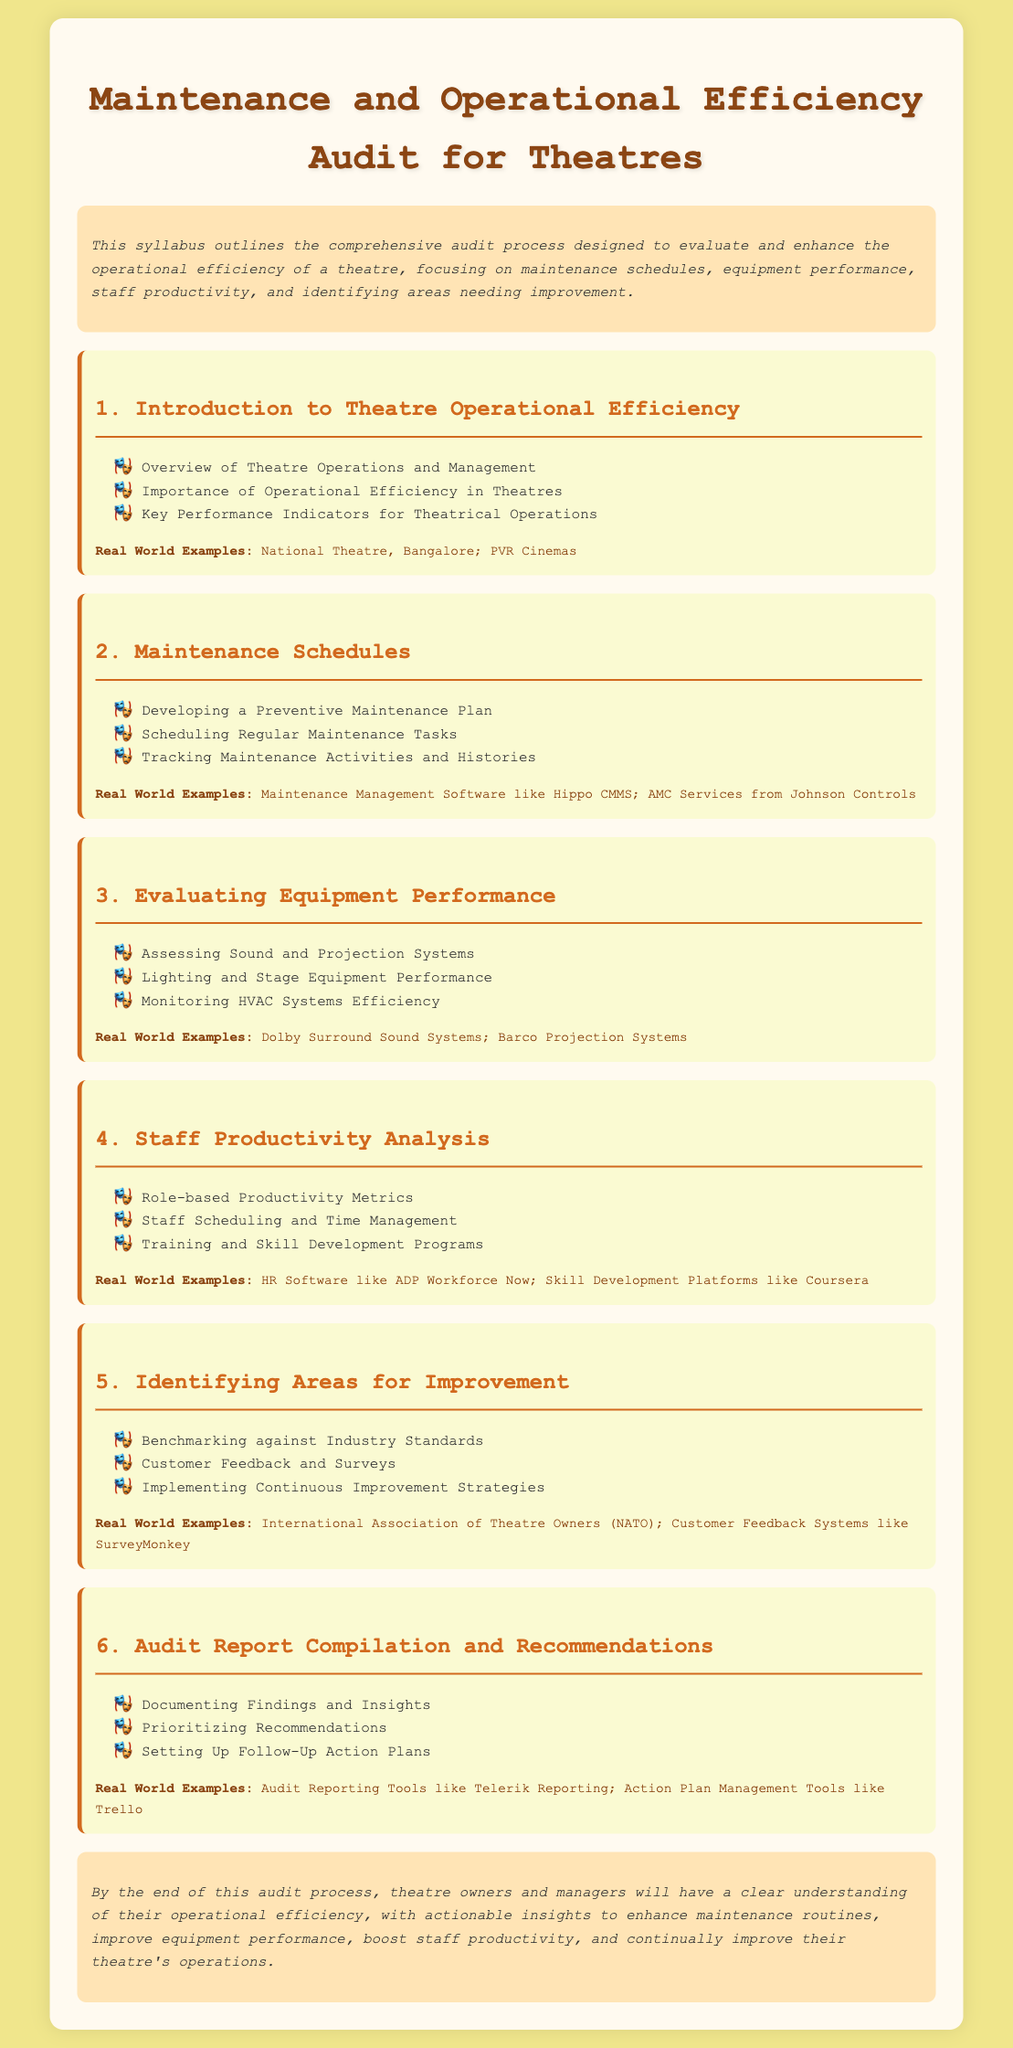What is the main purpose of the syllabus? The syllabus outlines the comprehensive audit process designed to evaluate and enhance the operational efficiency of a theatre.
Answer: Enhance operational efficiency What is included in the first module? The first module discusses the overview of theatre operations and management, importance of operational efficiency, and key performance indicators.
Answer: Overview, Importance, Key Performance Indicators Which software is mentioned for maintenance management? The document mentions Maintenance Management Software like Hippo CMMS.
Answer: Hippo CMMS How many areas for improvement are identified in the syllabus? The syllabus lists three areas for improvement: benchmarking, customer feedback, and continuous improvement strategies.
Answer: Three What type of tools are suggested for audit reporting? The syllabus suggests using Audit Reporting Tools like Telerik Reporting for compiling the audit report.
Answer: Telerik Reporting What is the focus of the third module? The third module focuses on evaluating equipment performance, including assessment of sound and projection systems, lighting, and HVAC systems.
Answer: Equipment performance evaluation Which platforms are listed for skill development in the staff productivity analysis? The syllabus lists Skill Development Platforms like Coursera for staff training.
Answer: Coursera What is the concluding goal of the audit process? The concluding goal is to provide theatre owners and managers with actionable insights to enhance their theatre's operations.
Answer: Actionable insights 